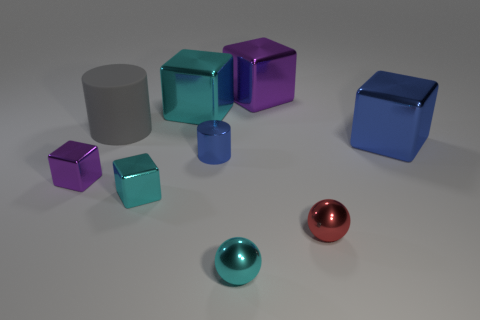What is the size of the block that is the same color as the small metallic cylinder?
Provide a succinct answer. Large. There is a object that is the same color as the tiny shiny cylinder; what is it made of?
Ensure brevity in your answer.  Metal. Is there a rubber cube of the same color as the large cylinder?
Give a very brief answer. No. Is the big cylinder the same color as the tiny metallic cylinder?
Your answer should be compact. No. The rubber cylinder is what color?
Give a very brief answer. Gray. How many cyan objects have the same shape as the tiny red shiny thing?
Give a very brief answer. 1. Do the purple cube that is to the right of the big gray rubber thing and the large cube in front of the big gray object have the same material?
Provide a succinct answer. Yes. There is a cylinder in front of the large metallic cube in front of the gray rubber thing; what is its size?
Ensure brevity in your answer.  Small. There is another object that is the same shape as the big rubber thing; what is it made of?
Keep it short and to the point. Metal. Does the metal thing that is in front of the red thing have the same shape as the blue object that is on the left side of the tiny red metallic object?
Ensure brevity in your answer.  No. 